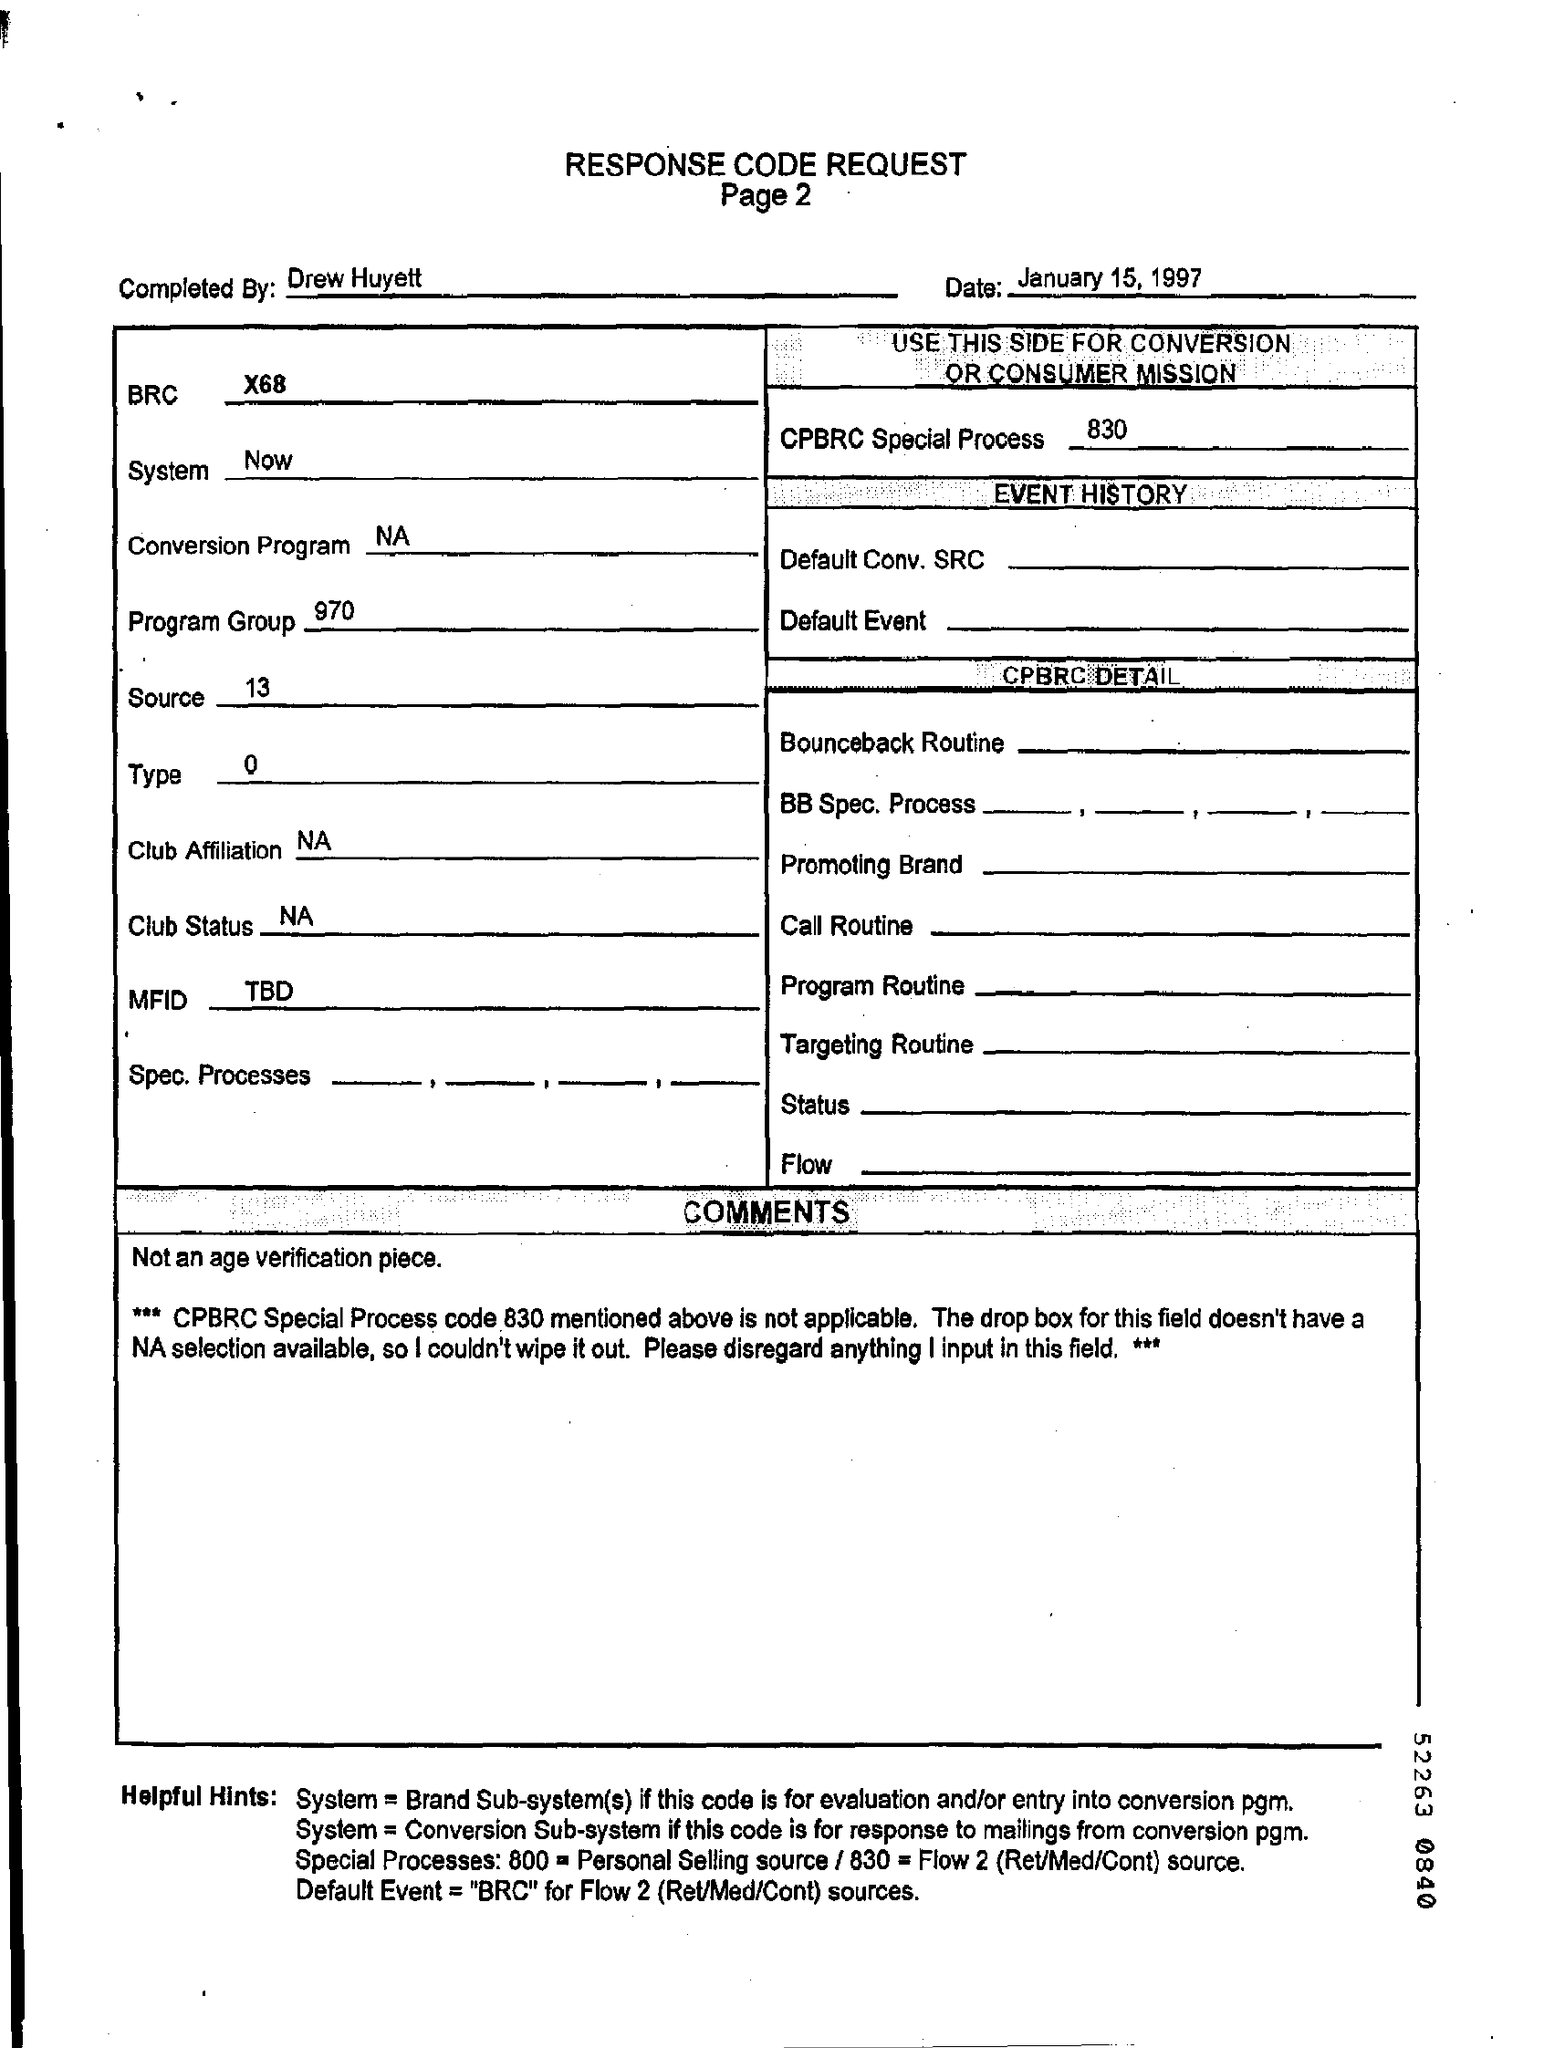Highlight a few significant elements in this photo. Can you please provide the program group number mentioned on the given page? The BRC mentioned on the page is X68.. The source number mentioned on the page is 13. The completion of the response code request was done by Drew Huyett. 